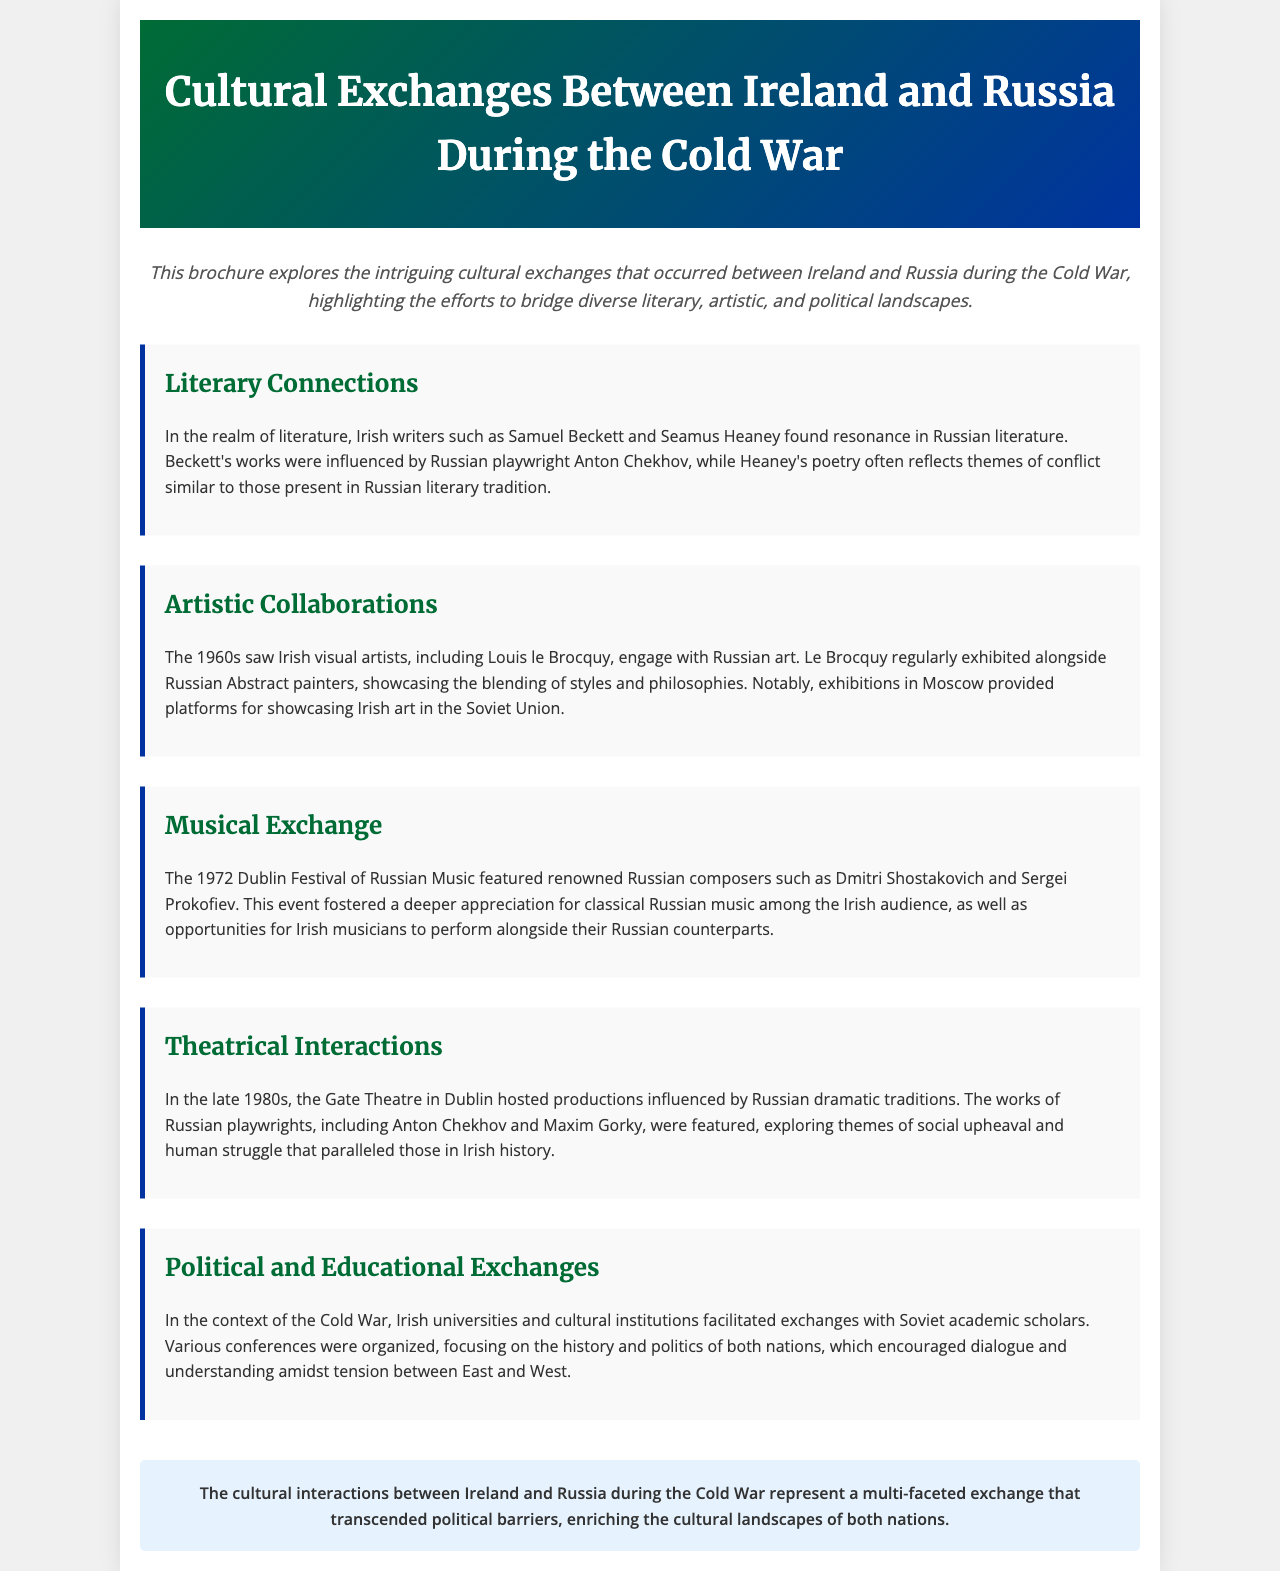what are the names of two Irish writers mentioned? The document references Samuel Beckett and Seamus Heaney as influential Irish writers.
Answer: Samuel Beckett, Seamus Heaney what artistic movement did Louis le Brocquy engage with? The document states that Louis le Brocquy engaged with Russian Abstract painters in the 1960s.
Answer: Russian Abstract what was featured in the 1972 Dublin Festival of Russian Music? The document mentions that renowned Russian composers like Dmitri Shostakovich and Sergei Prokofiev were part of the festival.
Answer: Dmitri Shostakovich, Sergei Prokofiev which Russian playwright's works influenced theatre productions in Dublin? The document points out Anton Chekhov and Maxim Gorky as Russian playwrights whose works were featured at the Gate Theatre.
Answer: Anton Chekhov, Maxim Gorky what type of exchanges did Irish universities facilitate during the Cold War? The document states that Irish universities facilitated political and educational exchanges with Soviet academic scholars.
Answer: Political and educational exchanges how did the cultural exchanges affect the two nations according to the conclusion? The document concludes that the exchanges transcended political barriers and enriched the cultural landscapes of both nations.
Answer: Enriched cultural landscapes what decade saw Irish visual artists engage with Russian art? The document indicates that the 1960s were when Irish visual artists engaged with Russian art.
Answer: 1960s what is the theme often reflected in Heaney's poetry? The document mentions that Heaney’s poetry reflects themes of conflict similar to those in Russian literary tradition.
Answer: Themes of conflict 